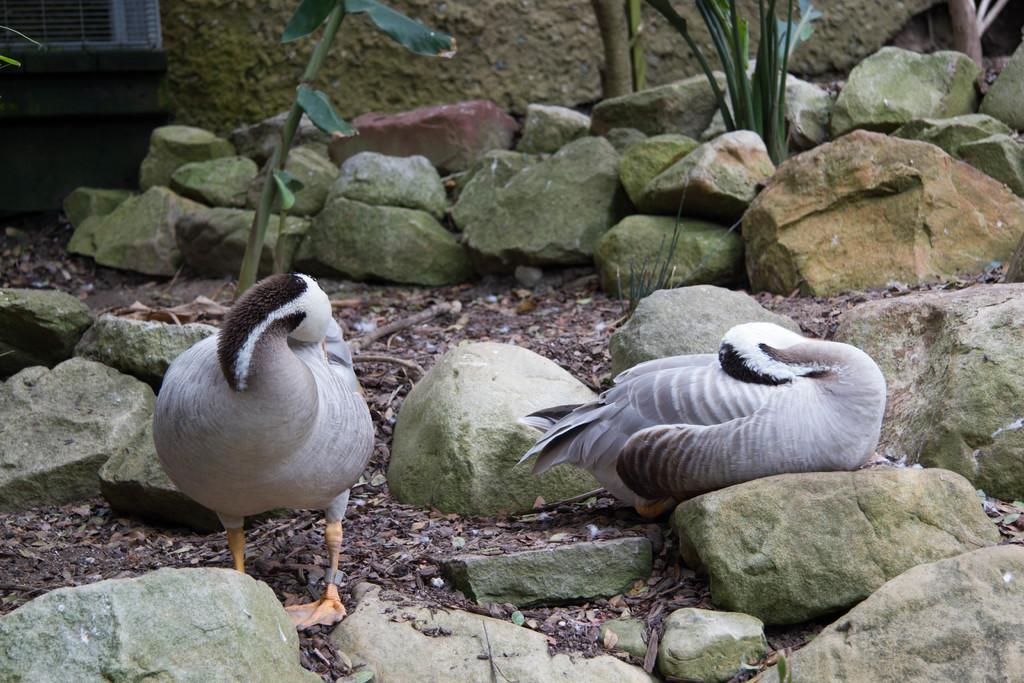How many birds are present in the image? There are two birds in the image. What colors can be seen on the birds? The birds are in ash, white, and black colors. What type of natural elements are visible in the image? There are many rocks and plants in the image. What can be seen in the background of the image? There is a wall visible in the background of the image. What type of cheese is being used to write on the wall in the image? There is no cheese or writing present in the image; it features two birds, rocks, plants, and a wall in the background. 